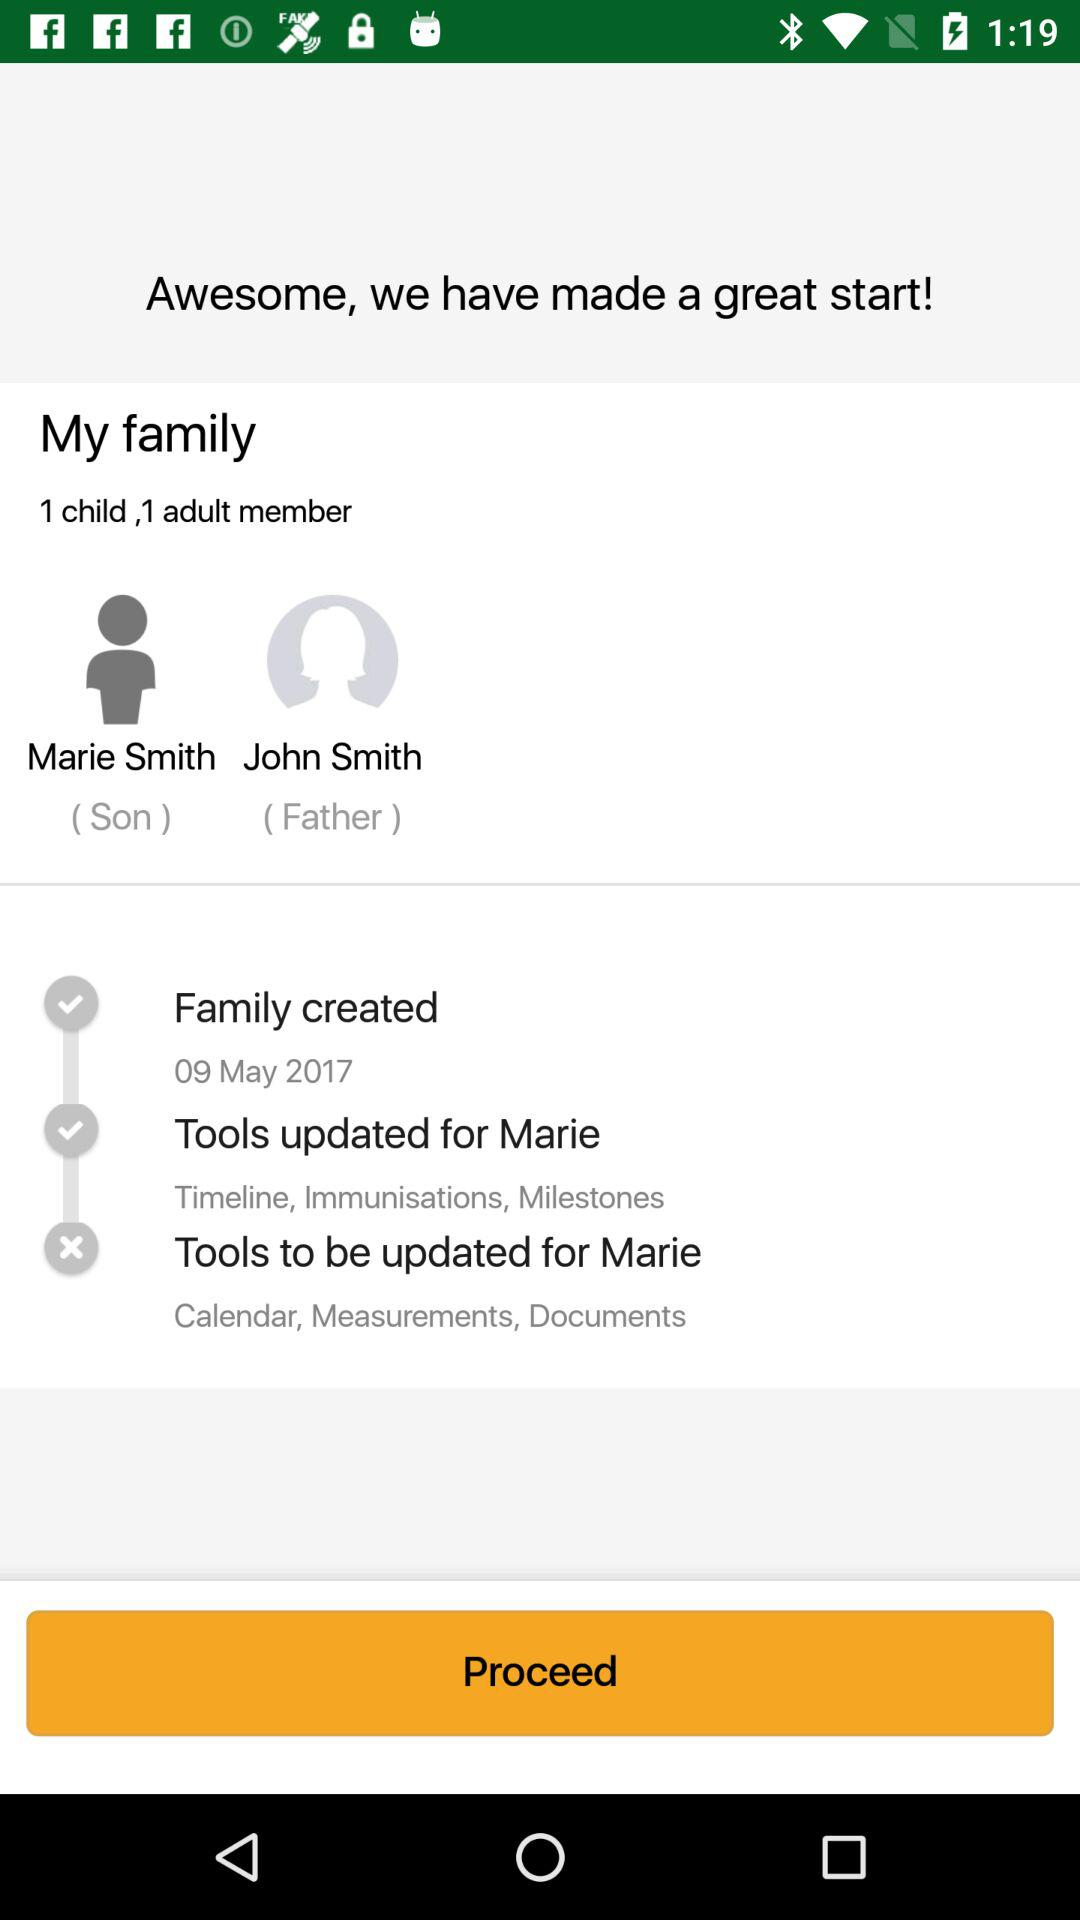How many members does this family have?
Answer the question using a single word or phrase. 2 